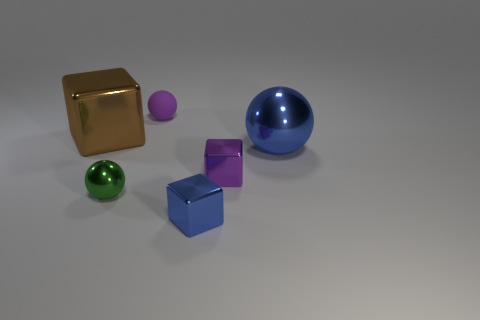Is there anything else that has the same material as the small purple sphere?
Your answer should be compact. No. What is the shape of the other tiny object that is the same color as the rubber thing?
Offer a very short reply. Cube. Are there any cubes of the same color as the small matte thing?
Provide a succinct answer. Yes. There is a shiny sphere that is right of the purple matte thing; is its color the same as the cube in front of the green metal ball?
Provide a succinct answer. Yes. What color is the thing that is both in front of the large blue metallic sphere and behind the tiny green object?
Give a very brief answer. Purple. There is a tiny metal cube that is behind the small green sphere; is it the same color as the matte object?
Ensure brevity in your answer.  Yes. How many balls are either cyan objects or green things?
Keep it short and to the point. 1. There is a small purple object that is behind the large block; what is its shape?
Keep it short and to the point. Sphere. What color is the small metallic object that is in front of the sphere that is in front of the purple thing on the right side of the matte ball?
Your response must be concise. Blue. Do the small purple sphere and the green ball have the same material?
Give a very brief answer. No. 